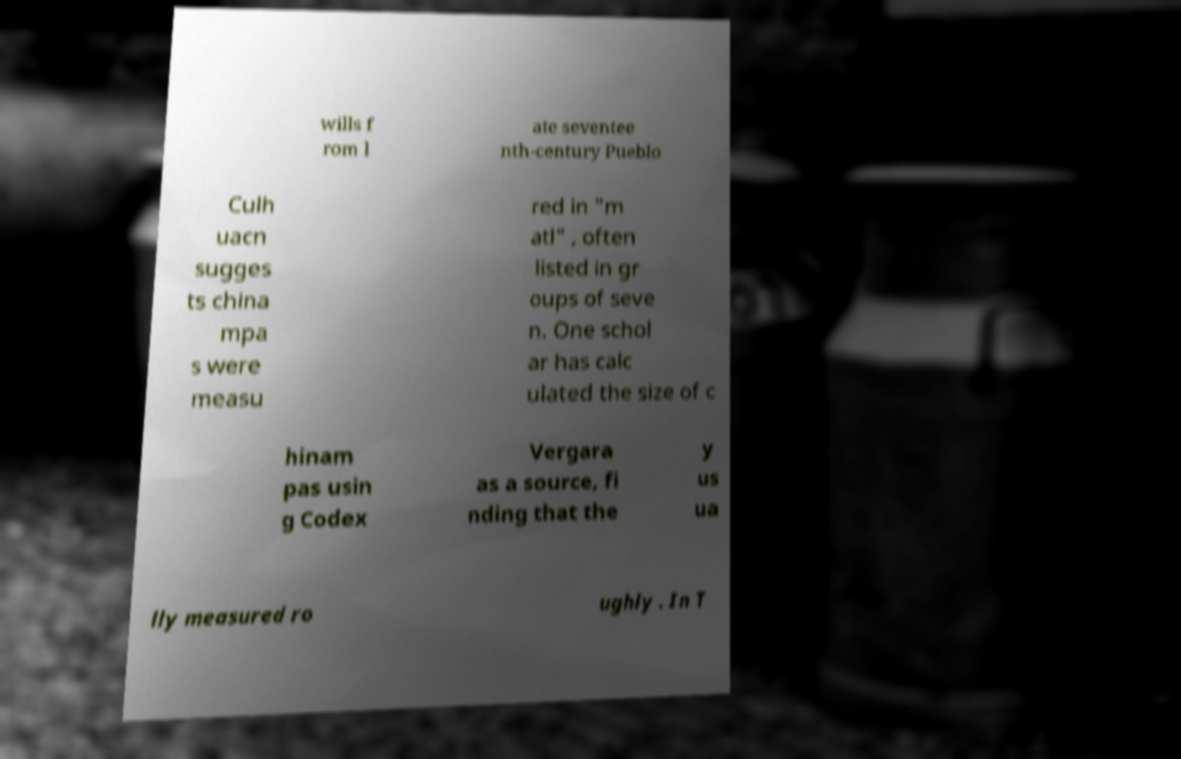Could you assist in decoding the text presented in this image and type it out clearly? wills f rom l ate seventee nth-century Pueblo Culh uacn sugges ts china mpa s were measu red in "m atl" , often listed in gr oups of seve n. One schol ar has calc ulated the size of c hinam pas usin g Codex Vergara as a source, fi nding that the y us ua lly measured ro ughly . In T 